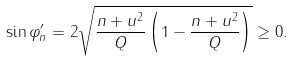Convert formula to latex. <formula><loc_0><loc_0><loc_500><loc_500>\sin \varphi _ { n } ^ { \prime } = 2 \sqrt { \frac { n + u ^ { 2 } } { Q } \left ( 1 - \frac { n + u ^ { 2 } } { Q } \right ) } \geq 0 .</formula> 